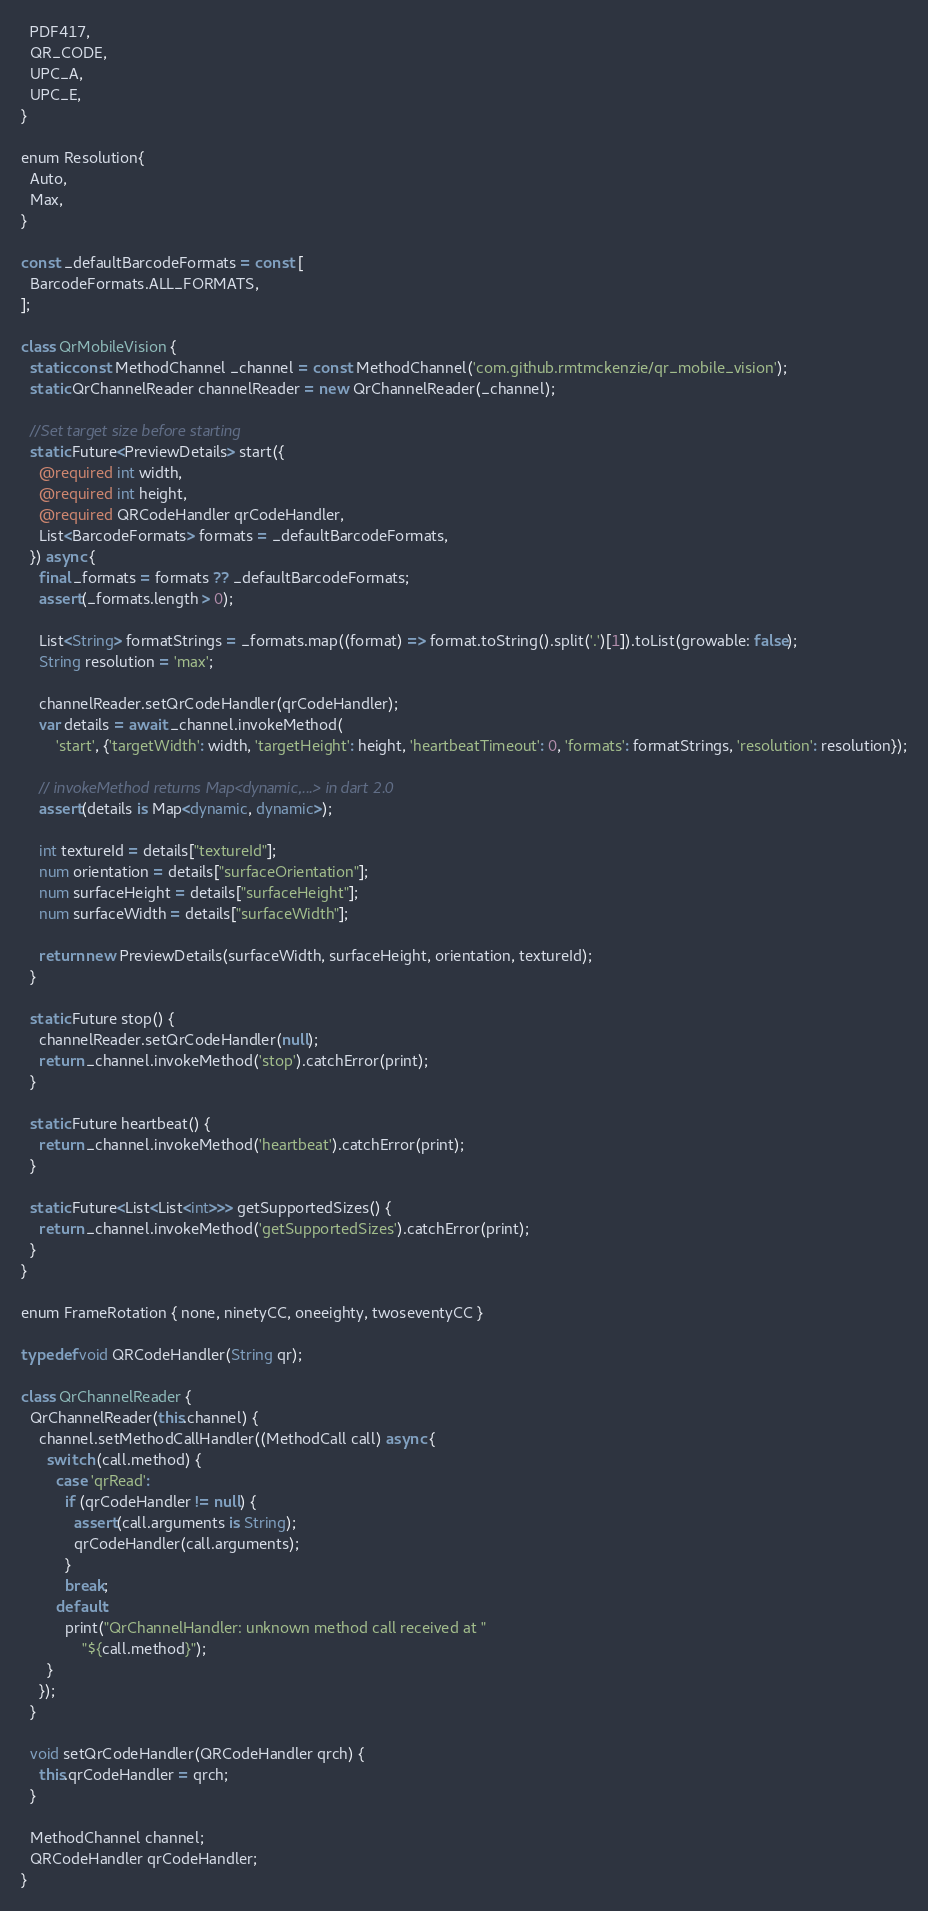Convert code to text. <code><loc_0><loc_0><loc_500><loc_500><_Dart_>  PDF417,
  QR_CODE,
  UPC_A,
  UPC_E,
}

enum Resolution{
  Auto,
  Max,
}

const _defaultBarcodeFormats = const [
  BarcodeFormats.ALL_FORMATS,
];

class QrMobileVision {
  static const MethodChannel _channel = const MethodChannel('com.github.rmtmckenzie/qr_mobile_vision');
  static QrChannelReader channelReader = new QrChannelReader(_channel);

  //Set target size before starting
  static Future<PreviewDetails> start({
    @required int width,
    @required int height,
    @required QRCodeHandler qrCodeHandler,
    List<BarcodeFormats> formats = _defaultBarcodeFormats,
  }) async {
    final _formats = formats ?? _defaultBarcodeFormats;
    assert(_formats.length > 0);

    List<String> formatStrings = _formats.map((format) => format.toString().split('.')[1]).toList(growable: false);
    String resolution = 'max';

    channelReader.setQrCodeHandler(qrCodeHandler);
    var details = await _channel.invokeMethod(
        'start', {'targetWidth': width, 'targetHeight': height, 'heartbeatTimeout': 0, 'formats': formatStrings, 'resolution': resolution});

    // invokeMethod returns Map<dynamic,...> in dart 2.0
    assert(details is Map<dynamic, dynamic>);

    int textureId = details["textureId"];
    num orientation = details["surfaceOrientation"];
    num surfaceHeight = details["surfaceHeight"];
    num surfaceWidth = details["surfaceWidth"];

    return new PreviewDetails(surfaceWidth, surfaceHeight, orientation, textureId);
  }

  static Future stop() {
    channelReader.setQrCodeHandler(null);
    return _channel.invokeMethod('stop').catchError(print);
  }

  static Future heartbeat() {
    return _channel.invokeMethod('heartbeat').catchError(print);
  }

  static Future<List<List<int>>> getSupportedSizes() {
    return _channel.invokeMethod('getSupportedSizes').catchError(print);
  }
}

enum FrameRotation { none, ninetyCC, oneeighty, twoseventyCC }

typedef void QRCodeHandler(String qr);

class QrChannelReader {
  QrChannelReader(this.channel) {
    channel.setMethodCallHandler((MethodCall call) async {
      switch (call.method) {
        case 'qrRead':
          if (qrCodeHandler != null) {
            assert(call.arguments is String);
            qrCodeHandler(call.arguments);
          }
          break;
        default:
          print("QrChannelHandler: unknown method call received at "
              "${call.method}");
      }
    });
  }

  void setQrCodeHandler(QRCodeHandler qrch) {
    this.qrCodeHandler = qrch;
  }

  MethodChannel channel;
  QRCodeHandler qrCodeHandler;
}
</code> 